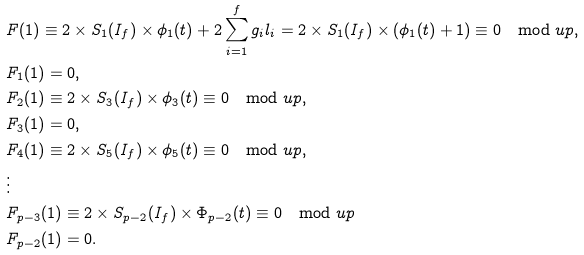<formula> <loc_0><loc_0><loc_500><loc_500>& F ( 1 ) \equiv 2 \times S _ { 1 } ( I _ { f } ) \times \phi _ { 1 } ( t ) + 2 \sum _ { i = 1 } ^ { f } g _ { i } l _ { i } = 2 \times S _ { 1 } ( I _ { f } ) \times ( \phi _ { 1 } ( t ) + 1 ) \equiv 0 \mod u p , \\ & F _ { 1 } ( 1 ) = 0 , \\ & F _ { 2 } ( 1 ) \equiv 2 \times S _ { 3 } ( I _ { f } ) \times \phi _ { 3 } ( t ) \equiv 0 \mod u p , \\ & F _ { 3 } ( 1 ) = 0 , \\ & F _ { 4 } ( 1 ) \equiv 2 \times S _ { 5 } ( I _ { f } ) \times \phi _ { 5 } ( t ) \equiv 0 \mod u p , \\ & \vdots \\ & F _ { p - 3 } ( 1 ) \equiv 2 \times S _ { p - 2 } ( I _ { f } ) \times \Phi _ { p - 2 } ( t ) \equiv 0 \mod u p \\ & F _ { p - 2 } ( 1 ) = 0 .</formula> 